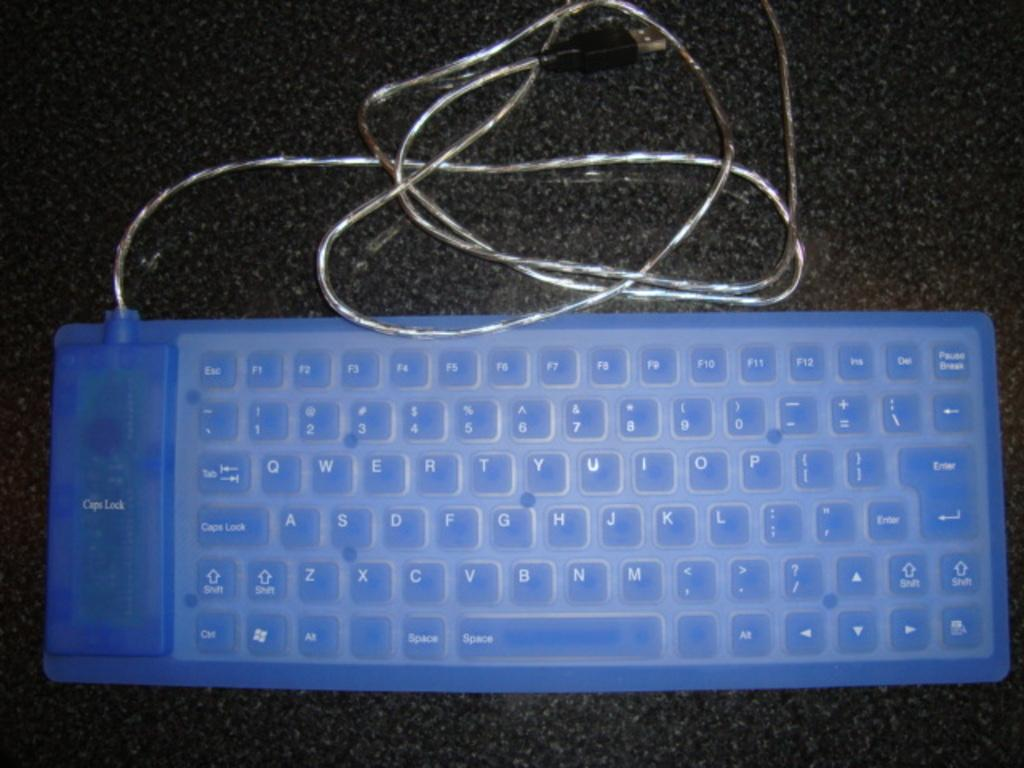<image>
Summarize the visual content of the image. A blue plastic keyboard shows the words Caps Lock in two different places. 